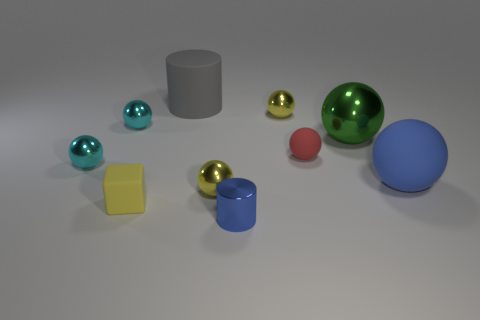Subtract all tiny rubber spheres. How many spheres are left? 6 Subtract all blue spheres. How many spheres are left? 6 Subtract all yellow spheres. Subtract all brown cylinders. How many spheres are left? 5 Subtract all cubes. How many objects are left? 9 Subtract 1 green spheres. How many objects are left? 9 Subtract all tiny yellow metallic spheres. Subtract all large gray cylinders. How many objects are left? 7 Add 5 tiny matte cubes. How many tiny matte cubes are left? 6 Add 5 green spheres. How many green spheres exist? 6 